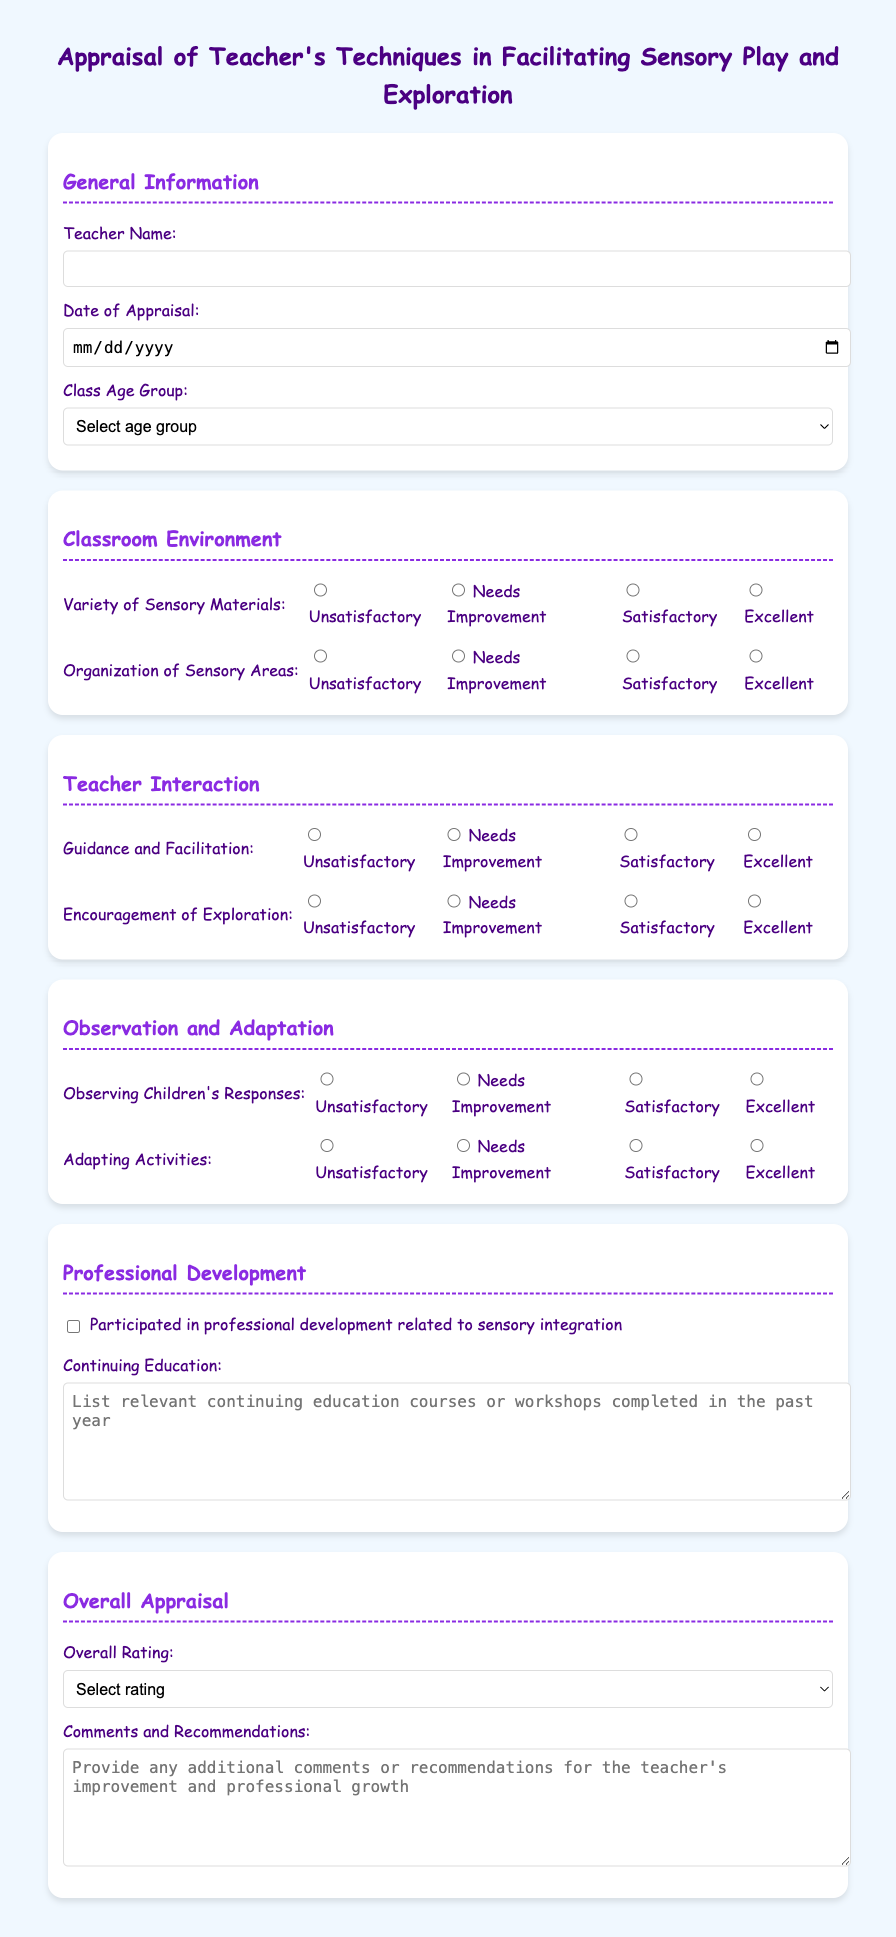What is the title of the document? The title can be found at the top of the document, summarizing its purpose.
Answer: Appraisal of Teacher's Techniques in Facilitating Sensory Play and Exploration What is the selected age group for the class? This information is gathered from the drop-down selection regarding age groups in the document.
Answer: 3-4 years What is required in the Overall Rating section? The Overall Rating section requires a selection that reflects the teacher's performance.
Answer: Select rating How many categories are used to evaluate the classroom environment? The document lists various categories in the evaluation section, specifically for the classroom environment.
Answer: 2 Which method is suggested for documenting continuing education? The document provides an area for input related to professional development that should be recorded.
Answer: List relevant continuing education courses or workshops completed in the past year What is the highest rating option available for the Observation and Adaptation section? The document specifies rating options for each evaluation area, including the highest rating.
Answer: Excellent What feedback is requested in the Comments and Recommendations section? This section asks for additional evaluations or suggestions for the teacher.
Answer: Provide any additional comments or recommendations for the teacher's improvement and professional growth How is the Teacher Interaction evaluated? This area is evaluated by rating specific aspects of teacher-student interaction.
Answer: Guidance and Facilitation, Encouragement of Exploration Did the teacher participate in professional development related to sensory integration? The document contains a checkbox to confirm participation in professional development.
Answer: Participated in professional development related to sensory integration 